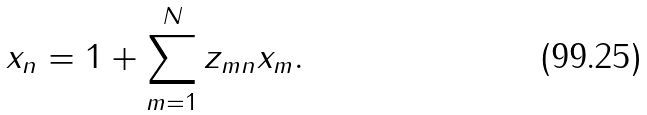Convert formula to latex. <formula><loc_0><loc_0><loc_500><loc_500>x _ { n } = 1 + \sum _ { m = 1 } ^ { N } z _ { m n } x _ { m } .</formula> 